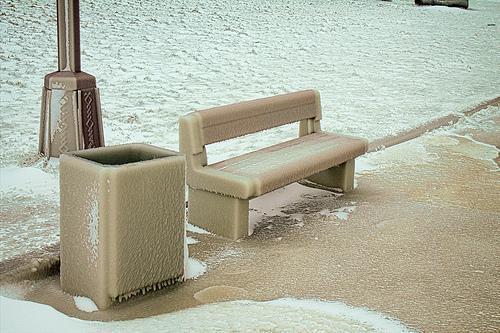How many benches are in this picture?
Give a very brief answer. 1. 